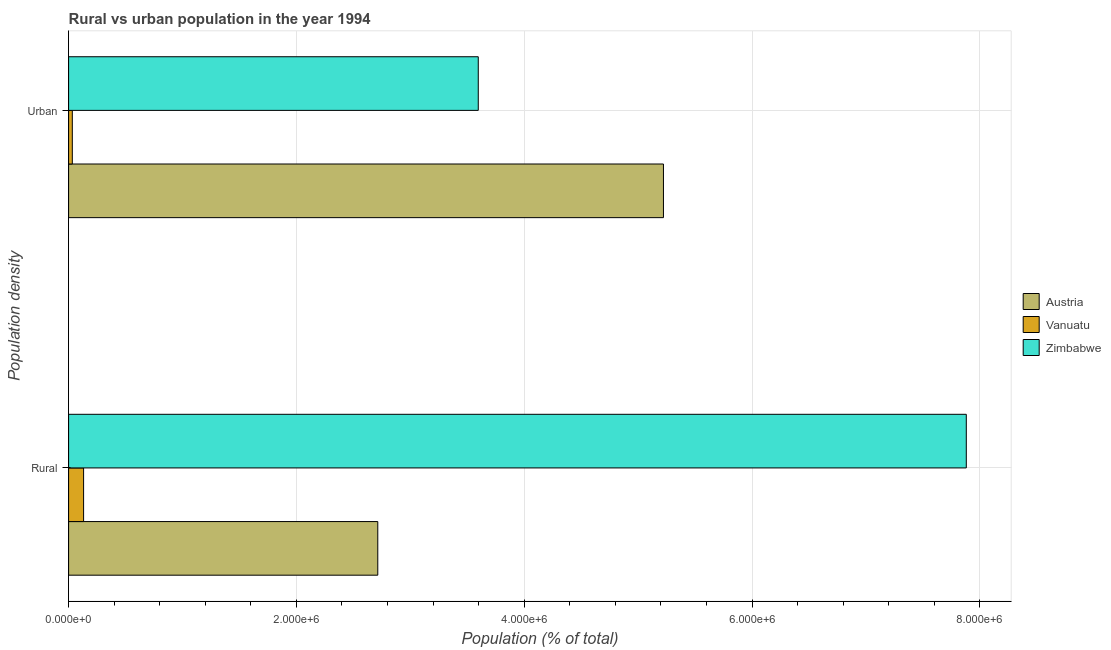How many different coloured bars are there?
Make the answer very short. 3. How many groups of bars are there?
Give a very brief answer. 2. How many bars are there on the 1st tick from the bottom?
Make the answer very short. 3. What is the label of the 1st group of bars from the top?
Offer a terse response. Urban. What is the rural population density in Austria?
Keep it short and to the point. 2.71e+06. Across all countries, what is the maximum rural population density?
Provide a short and direct response. 7.88e+06. Across all countries, what is the minimum rural population density?
Make the answer very short. 1.32e+05. In which country was the rural population density maximum?
Offer a terse response. Zimbabwe. In which country was the rural population density minimum?
Ensure brevity in your answer.  Vanuatu. What is the total urban population density in the graph?
Make the answer very short. 8.85e+06. What is the difference between the rural population density in Vanuatu and that in Austria?
Keep it short and to the point. -2.58e+06. What is the difference between the rural population density in Zimbabwe and the urban population density in Vanuatu?
Offer a very short reply. 7.85e+06. What is the average rural population density per country?
Provide a succinct answer. 3.58e+06. What is the difference between the urban population density and rural population density in Austria?
Keep it short and to the point. 2.51e+06. What is the ratio of the urban population density in Zimbabwe to that in Austria?
Keep it short and to the point. 0.69. In how many countries, is the urban population density greater than the average urban population density taken over all countries?
Offer a very short reply. 2. What does the 1st bar from the top in Urban represents?
Give a very brief answer. Zimbabwe. What does the 3rd bar from the bottom in Urban represents?
Your response must be concise. Zimbabwe. How many countries are there in the graph?
Offer a terse response. 3. Does the graph contain grids?
Provide a succinct answer. Yes. Where does the legend appear in the graph?
Offer a terse response. Center right. How are the legend labels stacked?
Keep it short and to the point. Vertical. What is the title of the graph?
Provide a succinct answer. Rural vs urban population in the year 1994. What is the label or title of the X-axis?
Ensure brevity in your answer.  Population (% of total). What is the label or title of the Y-axis?
Your answer should be compact. Population density. What is the Population (% of total) of Austria in Rural?
Offer a very short reply. 2.71e+06. What is the Population (% of total) in Vanuatu in Rural?
Provide a short and direct response. 1.32e+05. What is the Population (% of total) of Zimbabwe in Rural?
Offer a terse response. 7.88e+06. What is the Population (% of total) in Austria in Urban?
Your answer should be compact. 5.22e+06. What is the Population (% of total) in Vanuatu in Urban?
Keep it short and to the point. 3.26e+04. What is the Population (% of total) in Zimbabwe in Urban?
Provide a succinct answer. 3.60e+06. Across all Population density, what is the maximum Population (% of total) of Austria?
Your answer should be very brief. 5.22e+06. Across all Population density, what is the maximum Population (% of total) in Vanuatu?
Provide a short and direct response. 1.32e+05. Across all Population density, what is the maximum Population (% of total) of Zimbabwe?
Provide a succinct answer. 7.88e+06. Across all Population density, what is the minimum Population (% of total) of Austria?
Ensure brevity in your answer.  2.71e+06. Across all Population density, what is the minimum Population (% of total) in Vanuatu?
Provide a short and direct response. 3.26e+04. Across all Population density, what is the minimum Population (% of total) of Zimbabwe?
Your response must be concise. 3.60e+06. What is the total Population (% of total) of Austria in the graph?
Offer a very short reply. 7.94e+06. What is the total Population (% of total) in Vanuatu in the graph?
Ensure brevity in your answer.  1.64e+05. What is the total Population (% of total) of Zimbabwe in the graph?
Make the answer very short. 1.15e+07. What is the difference between the Population (% of total) of Austria in Rural and that in Urban?
Give a very brief answer. -2.51e+06. What is the difference between the Population (% of total) in Vanuatu in Rural and that in Urban?
Your answer should be very brief. 9.90e+04. What is the difference between the Population (% of total) of Zimbabwe in Rural and that in Urban?
Your answer should be very brief. 4.28e+06. What is the difference between the Population (% of total) in Austria in Rural and the Population (% of total) in Vanuatu in Urban?
Provide a succinct answer. 2.68e+06. What is the difference between the Population (% of total) of Austria in Rural and the Population (% of total) of Zimbabwe in Urban?
Make the answer very short. -8.82e+05. What is the difference between the Population (% of total) in Vanuatu in Rural and the Population (% of total) in Zimbabwe in Urban?
Keep it short and to the point. -3.46e+06. What is the average Population (% of total) in Austria per Population density?
Your answer should be compact. 3.97e+06. What is the average Population (% of total) in Vanuatu per Population density?
Your response must be concise. 8.21e+04. What is the average Population (% of total) in Zimbabwe per Population density?
Your answer should be very brief. 5.74e+06. What is the difference between the Population (% of total) in Austria and Population (% of total) in Vanuatu in Rural?
Ensure brevity in your answer.  2.58e+06. What is the difference between the Population (% of total) in Austria and Population (% of total) in Zimbabwe in Rural?
Your response must be concise. -5.17e+06. What is the difference between the Population (% of total) of Vanuatu and Population (% of total) of Zimbabwe in Rural?
Offer a terse response. -7.75e+06. What is the difference between the Population (% of total) in Austria and Population (% of total) in Vanuatu in Urban?
Give a very brief answer. 5.19e+06. What is the difference between the Population (% of total) in Austria and Population (% of total) in Zimbabwe in Urban?
Keep it short and to the point. 1.63e+06. What is the difference between the Population (% of total) in Vanuatu and Population (% of total) in Zimbabwe in Urban?
Make the answer very short. -3.56e+06. What is the ratio of the Population (% of total) of Austria in Rural to that in Urban?
Give a very brief answer. 0.52. What is the ratio of the Population (% of total) of Vanuatu in Rural to that in Urban?
Your response must be concise. 4.03. What is the ratio of the Population (% of total) in Zimbabwe in Rural to that in Urban?
Offer a terse response. 2.19. What is the difference between the highest and the second highest Population (% of total) in Austria?
Your response must be concise. 2.51e+06. What is the difference between the highest and the second highest Population (% of total) in Vanuatu?
Give a very brief answer. 9.90e+04. What is the difference between the highest and the second highest Population (% of total) of Zimbabwe?
Give a very brief answer. 4.28e+06. What is the difference between the highest and the lowest Population (% of total) of Austria?
Your answer should be very brief. 2.51e+06. What is the difference between the highest and the lowest Population (% of total) of Vanuatu?
Offer a very short reply. 9.90e+04. What is the difference between the highest and the lowest Population (% of total) in Zimbabwe?
Provide a succinct answer. 4.28e+06. 